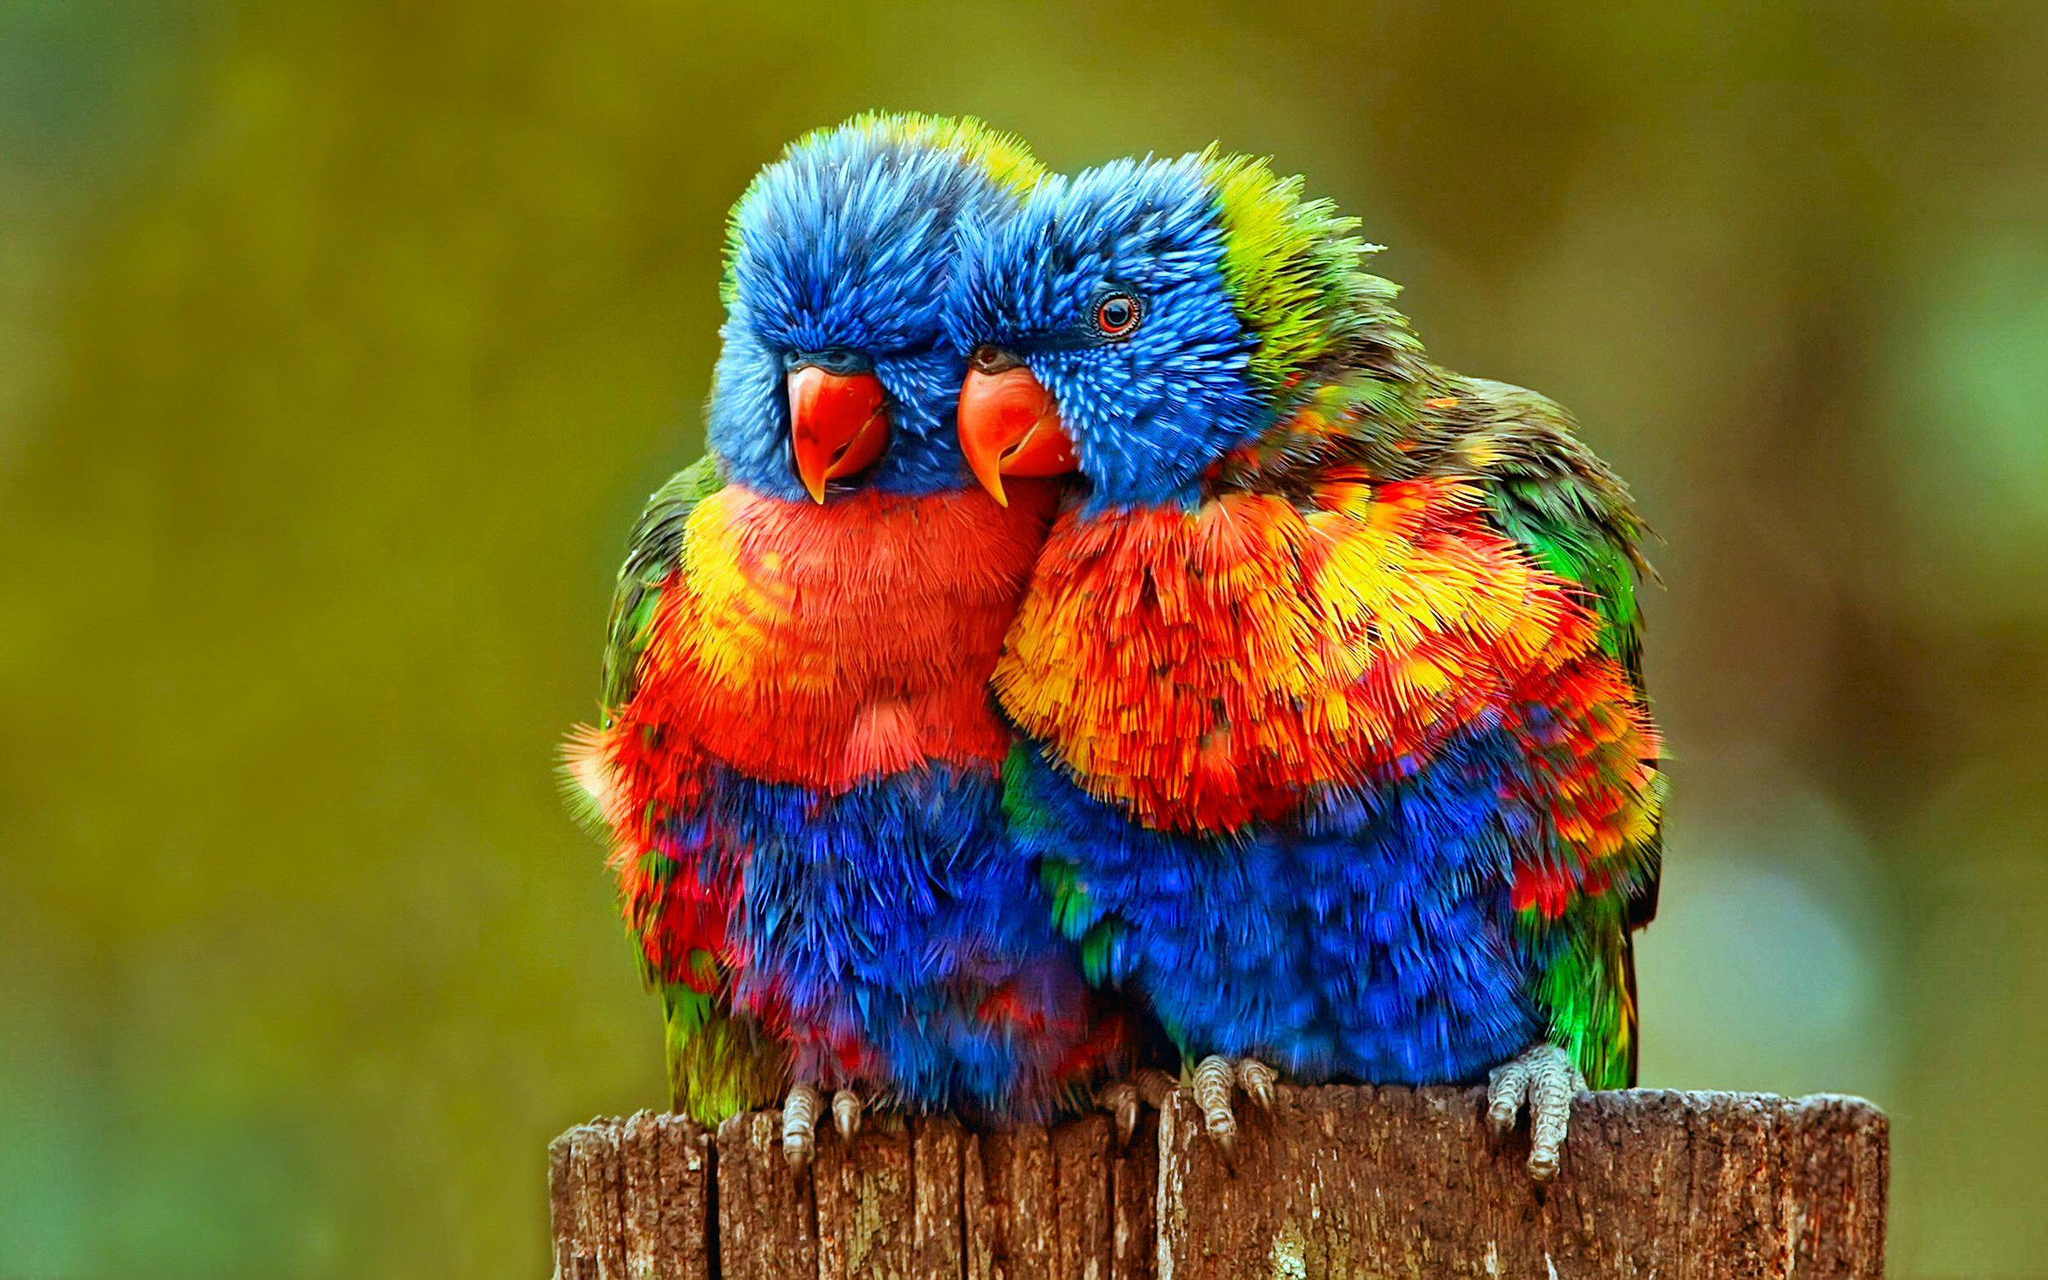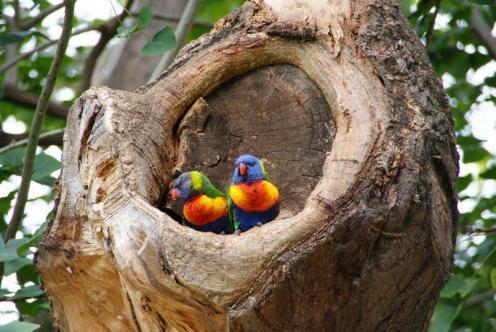The first image is the image on the left, the second image is the image on the right. Evaluate the accuracy of this statement regarding the images: "There's no more than one parrot in the right image.". Is it true? Answer yes or no. No. The first image is the image on the left, the second image is the image on the right. Considering the images on both sides, is "An image features a horizontal row of at least four perched blue-headed parrots." valid? Answer yes or no. No. 